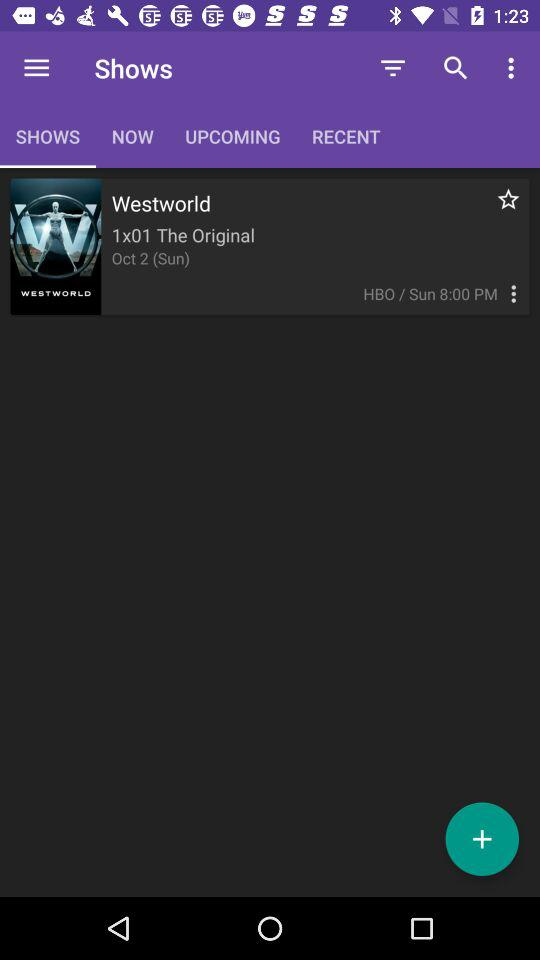What is the date? The date is Sunday, October 2. 